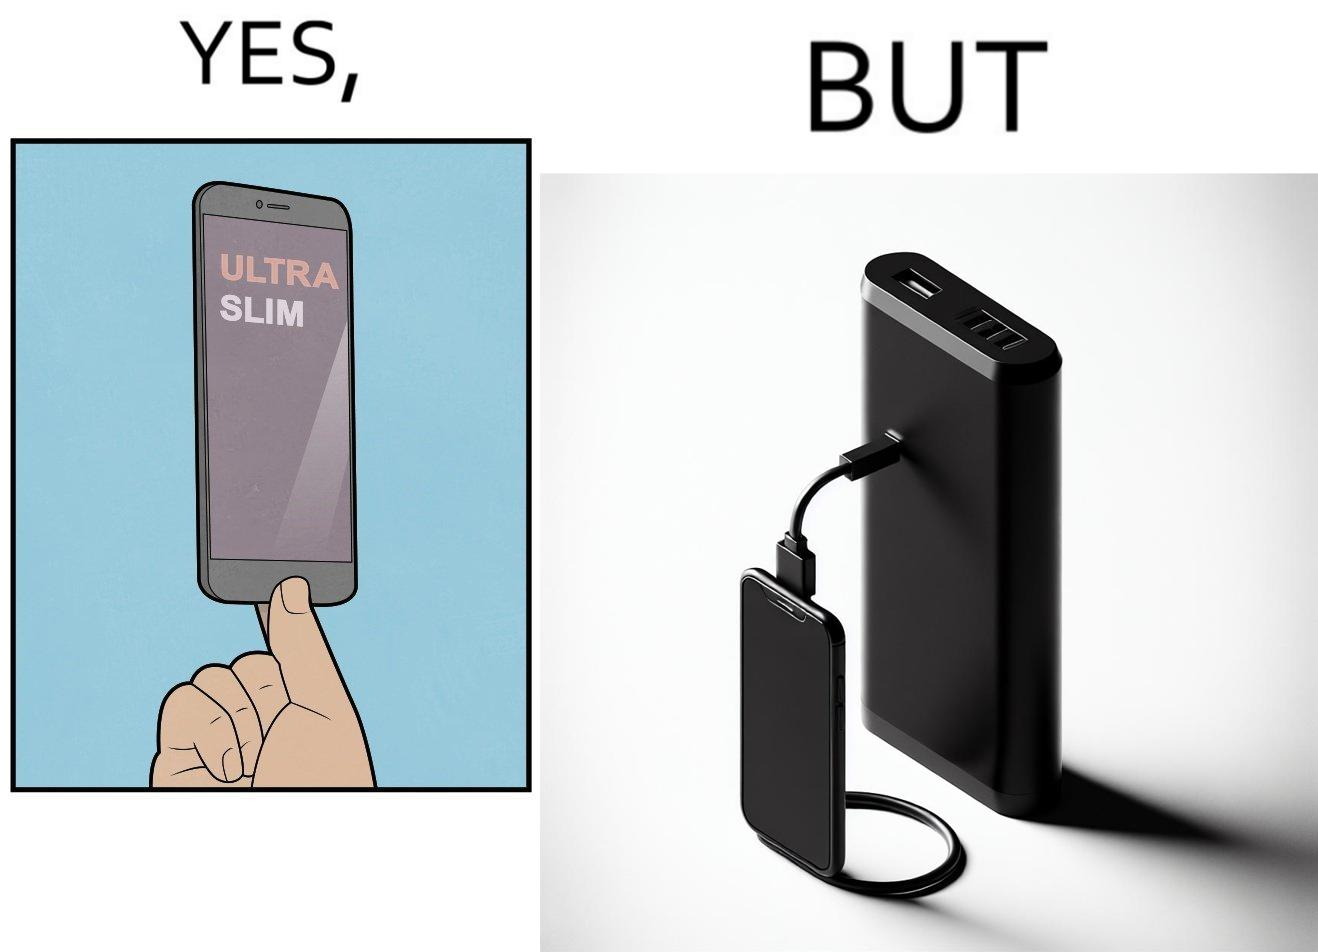Describe what you see in this image. The image is satirical because even though the mobile phone has been developed to be very slim, it requires frequent recharging which makes the mobile phone useless without a big, heavy and thick power bank. 